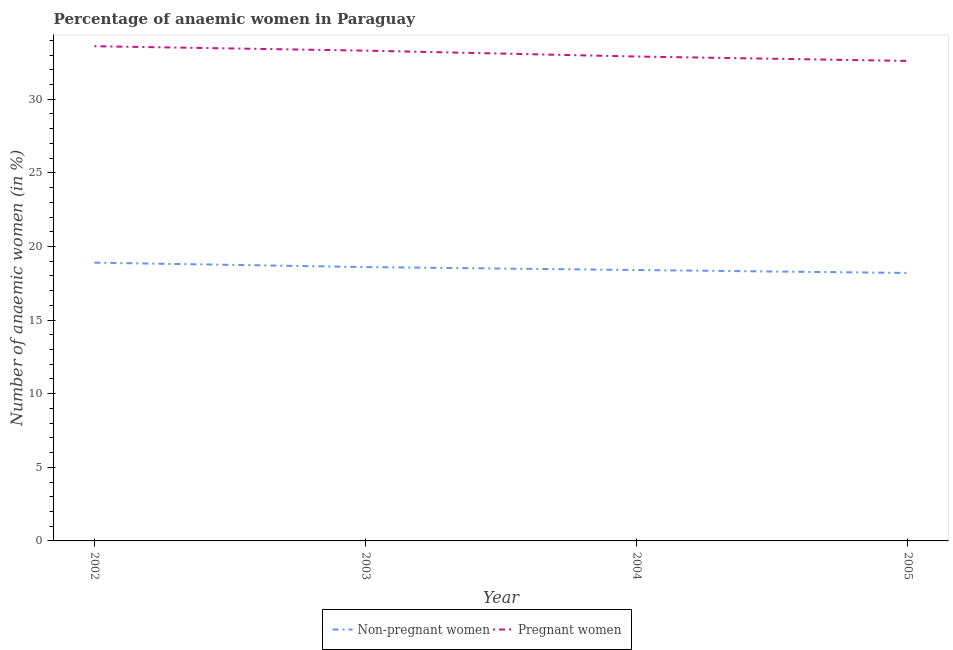Does the line corresponding to percentage of non-pregnant anaemic women intersect with the line corresponding to percentage of pregnant anaemic women?
Provide a succinct answer. No. Is the number of lines equal to the number of legend labels?
Offer a very short reply. Yes. Across all years, what is the maximum percentage of non-pregnant anaemic women?
Ensure brevity in your answer.  18.9. Across all years, what is the minimum percentage of pregnant anaemic women?
Ensure brevity in your answer.  32.6. In which year was the percentage of pregnant anaemic women maximum?
Offer a very short reply. 2002. In which year was the percentage of pregnant anaemic women minimum?
Make the answer very short. 2005. What is the total percentage of pregnant anaemic women in the graph?
Your answer should be compact. 132.4. What is the difference between the percentage of non-pregnant anaemic women in 2002 and that in 2005?
Make the answer very short. 0.7. What is the difference between the percentage of pregnant anaemic women in 2003 and the percentage of non-pregnant anaemic women in 2002?
Make the answer very short. 14.4. What is the average percentage of non-pregnant anaemic women per year?
Offer a terse response. 18.52. In the year 2003, what is the difference between the percentage of pregnant anaemic women and percentage of non-pregnant anaemic women?
Provide a succinct answer. 14.7. In how many years, is the percentage of non-pregnant anaemic women greater than 2 %?
Offer a terse response. 4. What is the ratio of the percentage of non-pregnant anaemic women in 2003 to that in 2005?
Offer a terse response. 1.02. Is the percentage of pregnant anaemic women in 2003 less than that in 2004?
Provide a succinct answer. No. What is the difference between the highest and the second highest percentage of non-pregnant anaemic women?
Keep it short and to the point. 0.3. What is the difference between the highest and the lowest percentage of non-pregnant anaemic women?
Your answer should be compact. 0.7. In how many years, is the percentage of non-pregnant anaemic women greater than the average percentage of non-pregnant anaemic women taken over all years?
Give a very brief answer. 2. Is the percentage of pregnant anaemic women strictly greater than the percentage of non-pregnant anaemic women over the years?
Give a very brief answer. Yes. How many years are there in the graph?
Your answer should be very brief. 4. Are the values on the major ticks of Y-axis written in scientific E-notation?
Your response must be concise. No. Where does the legend appear in the graph?
Ensure brevity in your answer.  Bottom center. What is the title of the graph?
Keep it short and to the point. Percentage of anaemic women in Paraguay. Does "Central government" appear as one of the legend labels in the graph?
Give a very brief answer. No. What is the label or title of the Y-axis?
Your answer should be very brief. Number of anaemic women (in %). What is the Number of anaemic women (in %) of Pregnant women in 2002?
Give a very brief answer. 33.6. What is the Number of anaemic women (in %) of Pregnant women in 2003?
Provide a short and direct response. 33.3. What is the Number of anaemic women (in %) in Non-pregnant women in 2004?
Offer a very short reply. 18.4. What is the Number of anaemic women (in %) of Pregnant women in 2004?
Provide a succinct answer. 32.9. What is the Number of anaemic women (in %) of Pregnant women in 2005?
Offer a very short reply. 32.6. Across all years, what is the maximum Number of anaemic women (in %) of Non-pregnant women?
Your answer should be very brief. 18.9. Across all years, what is the maximum Number of anaemic women (in %) of Pregnant women?
Offer a very short reply. 33.6. Across all years, what is the minimum Number of anaemic women (in %) of Non-pregnant women?
Keep it short and to the point. 18.2. Across all years, what is the minimum Number of anaemic women (in %) in Pregnant women?
Offer a very short reply. 32.6. What is the total Number of anaemic women (in %) in Non-pregnant women in the graph?
Offer a very short reply. 74.1. What is the total Number of anaemic women (in %) in Pregnant women in the graph?
Your answer should be compact. 132.4. What is the difference between the Number of anaemic women (in %) of Non-pregnant women in 2002 and that in 2003?
Your response must be concise. 0.3. What is the difference between the Number of anaemic women (in %) of Non-pregnant women in 2002 and that in 2005?
Provide a succinct answer. 0.7. What is the difference between the Number of anaemic women (in %) in Pregnant women in 2002 and that in 2005?
Make the answer very short. 1. What is the difference between the Number of anaemic women (in %) of Non-pregnant women in 2003 and that in 2004?
Your answer should be compact. 0.2. What is the difference between the Number of anaemic women (in %) of Pregnant women in 2004 and that in 2005?
Offer a very short reply. 0.3. What is the difference between the Number of anaemic women (in %) of Non-pregnant women in 2002 and the Number of anaemic women (in %) of Pregnant women in 2003?
Provide a short and direct response. -14.4. What is the difference between the Number of anaemic women (in %) in Non-pregnant women in 2002 and the Number of anaemic women (in %) in Pregnant women in 2005?
Ensure brevity in your answer.  -13.7. What is the difference between the Number of anaemic women (in %) in Non-pregnant women in 2003 and the Number of anaemic women (in %) in Pregnant women in 2004?
Ensure brevity in your answer.  -14.3. What is the difference between the Number of anaemic women (in %) of Non-pregnant women in 2004 and the Number of anaemic women (in %) of Pregnant women in 2005?
Give a very brief answer. -14.2. What is the average Number of anaemic women (in %) of Non-pregnant women per year?
Provide a succinct answer. 18.52. What is the average Number of anaemic women (in %) of Pregnant women per year?
Provide a succinct answer. 33.1. In the year 2002, what is the difference between the Number of anaemic women (in %) in Non-pregnant women and Number of anaemic women (in %) in Pregnant women?
Offer a very short reply. -14.7. In the year 2003, what is the difference between the Number of anaemic women (in %) of Non-pregnant women and Number of anaemic women (in %) of Pregnant women?
Keep it short and to the point. -14.7. In the year 2004, what is the difference between the Number of anaemic women (in %) in Non-pregnant women and Number of anaemic women (in %) in Pregnant women?
Your answer should be compact. -14.5. In the year 2005, what is the difference between the Number of anaemic women (in %) in Non-pregnant women and Number of anaemic women (in %) in Pregnant women?
Give a very brief answer. -14.4. What is the ratio of the Number of anaemic women (in %) in Non-pregnant women in 2002 to that in 2003?
Provide a succinct answer. 1.02. What is the ratio of the Number of anaemic women (in %) of Pregnant women in 2002 to that in 2003?
Provide a short and direct response. 1.01. What is the ratio of the Number of anaemic women (in %) in Non-pregnant women in 2002 to that in 2004?
Offer a very short reply. 1.03. What is the ratio of the Number of anaemic women (in %) of Pregnant women in 2002 to that in 2004?
Make the answer very short. 1.02. What is the ratio of the Number of anaemic women (in %) of Pregnant women in 2002 to that in 2005?
Your answer should be very brief. 1.03. What is the ratio of the Number of anaemic women (in %) of Non-pregnant women in 2003 to that in 2004?
Provide a short and direct response. 1.01. What is the ratio of the Number of anaemic women (in %) in Pregnant women in 2003 to that in 2004?
Provide a succinct answer. 1.01. What is the ratio of the Number of anaemic women (in %) of Pregnant women in 2003 to that in 2005?
Give a very brief answer. 1.02. What is the ratio of the Number of anaemic women (in %) of Non-pregnant women in 2004 to that in 2005?
Make the answer very short. 1.01. What is the ratio of the Number of anaemic women (in %) in Pregnant women in 2004 to that in 2005?
Your answer should be very brief. 1.01. What is the difference between the highest and the second highest Number of anaemic women (in %) in Non-pregnant women?
Make the answer very short. 0.3. What is the difference between the highest and the lowest Number of anaemic women (in %) of Pregnant women?
Make the answer very short. 1. 